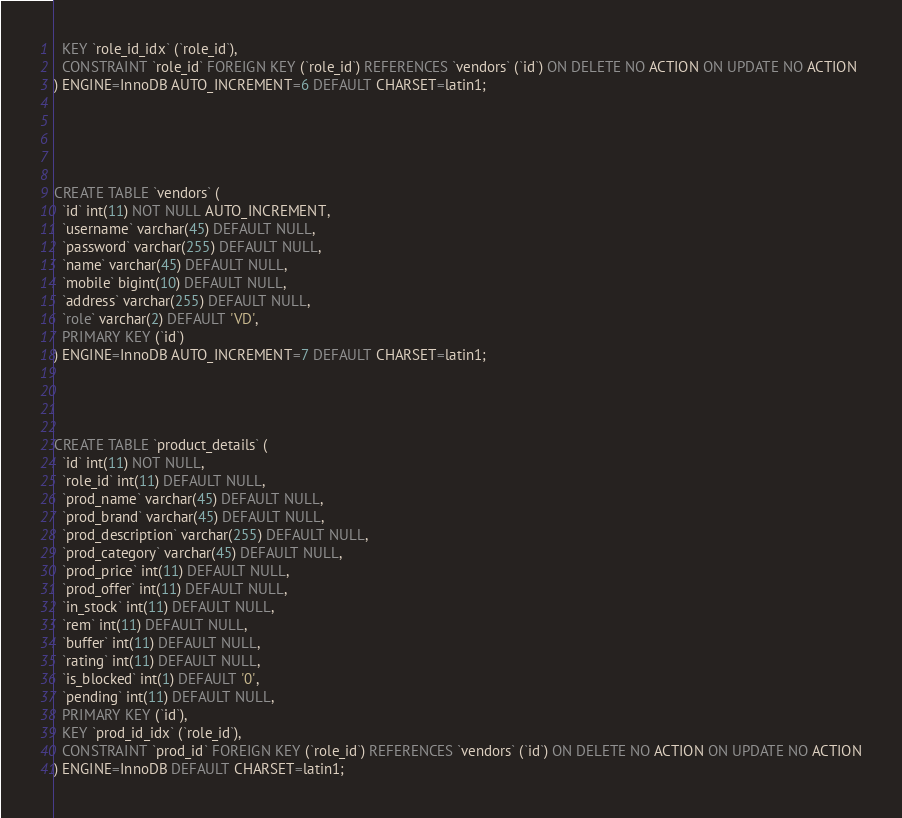Convert code to text. <code><loc_0><loc_0><loc_500><loc_500><_SQL_>  KEY `role_id_idx` (`role_id`),
  CONSTRAINT `role_id` FOREIGN KEY (`role_id`) REFERENCES `vendors` (`id`) ON DELETE NO ACTION ON UPDATE NO ACTION
) ENGINE=InnoDB AUTO_INCREMENT=6 DEFAULT CHARSET=latin1;





CREATE TABLE `vendors` (
  `id` int(11) NOT NULL AUTO_INCREMENT,
  `username` varchar(45) DEFAULT NULL,
  `password` varchar(255) DEFAULT NULL,
  `name` varchar(45) DEFAULT NULL,
  `mobile` bigint(10) DEFAULT NULL,
  `address` varchar(255) DEFAULT NULL,
  `role` varchar(2) DEFAULT 'VD',
  PRIMARY KEY (`id`)
) ENGINE=InnoDB AUTO_INCREMENT=7 DEFAULT CHARSET=latin1;




CREATE TABLE `product_details` (
  `id` int(11) NOT NULL,
  `role_id` int(11) DEFAULT NULL,
  `prod_name` varchar(45) DEFAULT NULL,
  `prod_brand` varchar(45) DEFAULT NULL,
  `prod_description` varchar(255) DEFAULT NULL,
  `prod_category` varchar(45) DEFAULT NULL,
  `prod_price` int(11) DEFAULT NULL,
  `prod_offer` int(11) DEFAULT NULL,
  `in_stock` int(11) DEFAULT NULL,
  `rem` int(11) DEFAULT NULL,
  `buffer` int(11) DEFAULT NULL,
  `rating` int(11) DEFAULT NULL,
  `is_blocked` int(1) DEFAULT '0',
  `pending` int(11) DEFAULT NULL,
  PRIMARY KEY (`id`),
  KEY `prod_id_idx` (`role_id`),
  CONSTRAINT `prod_id` FOREIGN KEY (`role_id`) REFERENCES `vendors` (`id`) ON DELETE NO ACTION ON UPDATE NO ACTION
) ENGINE=InnoDB DEFAULT CHARSET=latin1;
</code> 